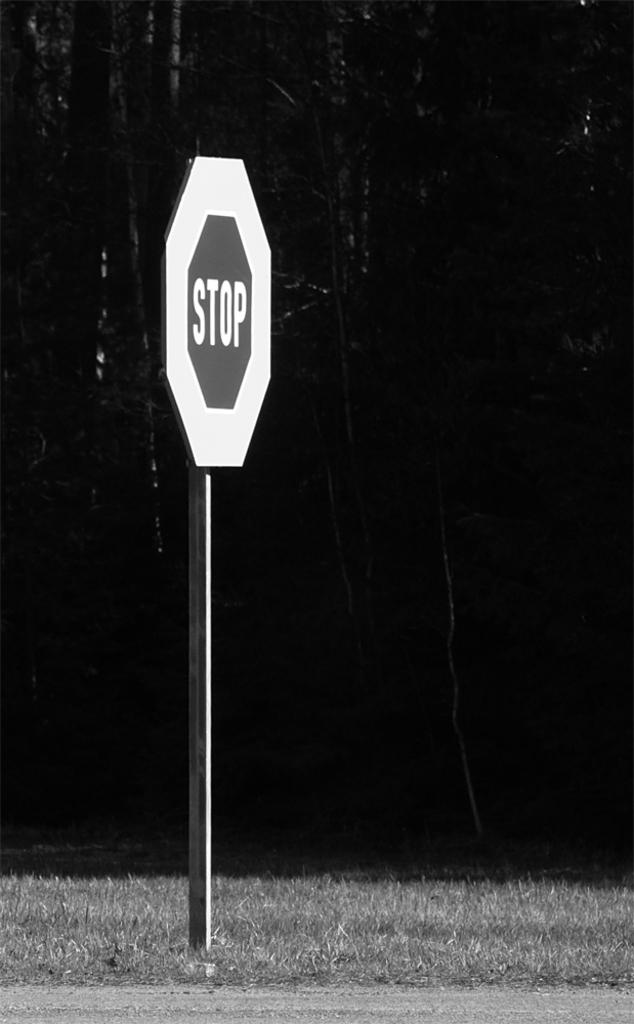<image>
Summarize the visual content of the image. A stop sign with a thick border is attached to a pole in the grass. 